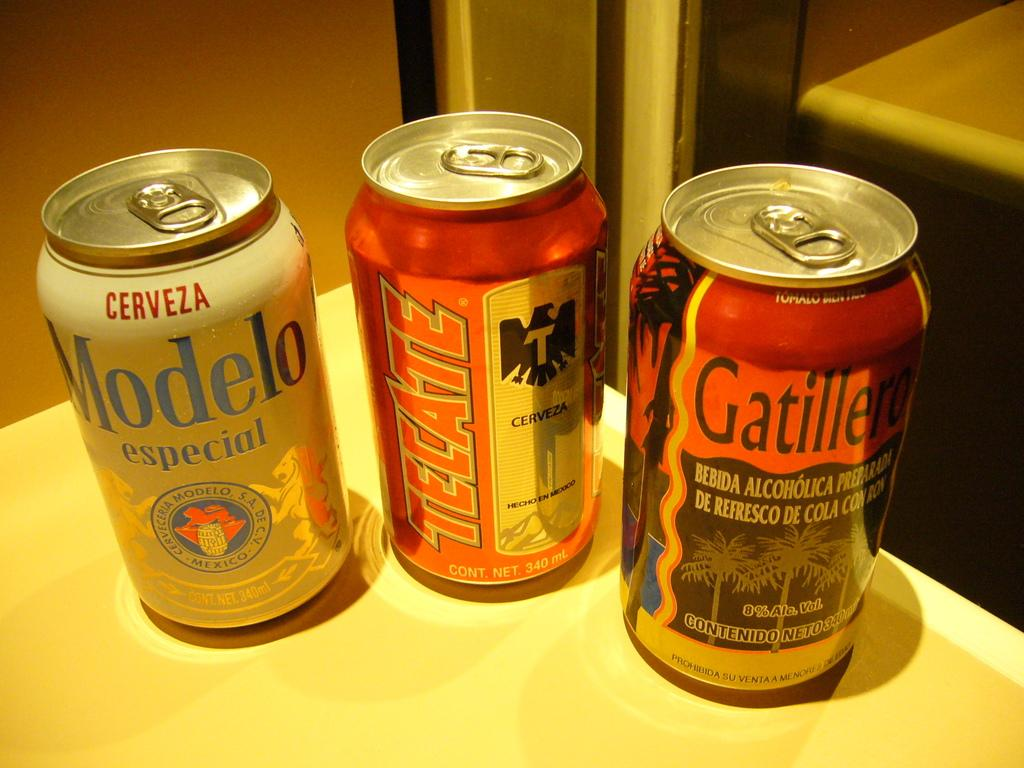<image>
Write a terse but informative summary of the picture. A can of Modelo beer sits next to 2 other cans. 